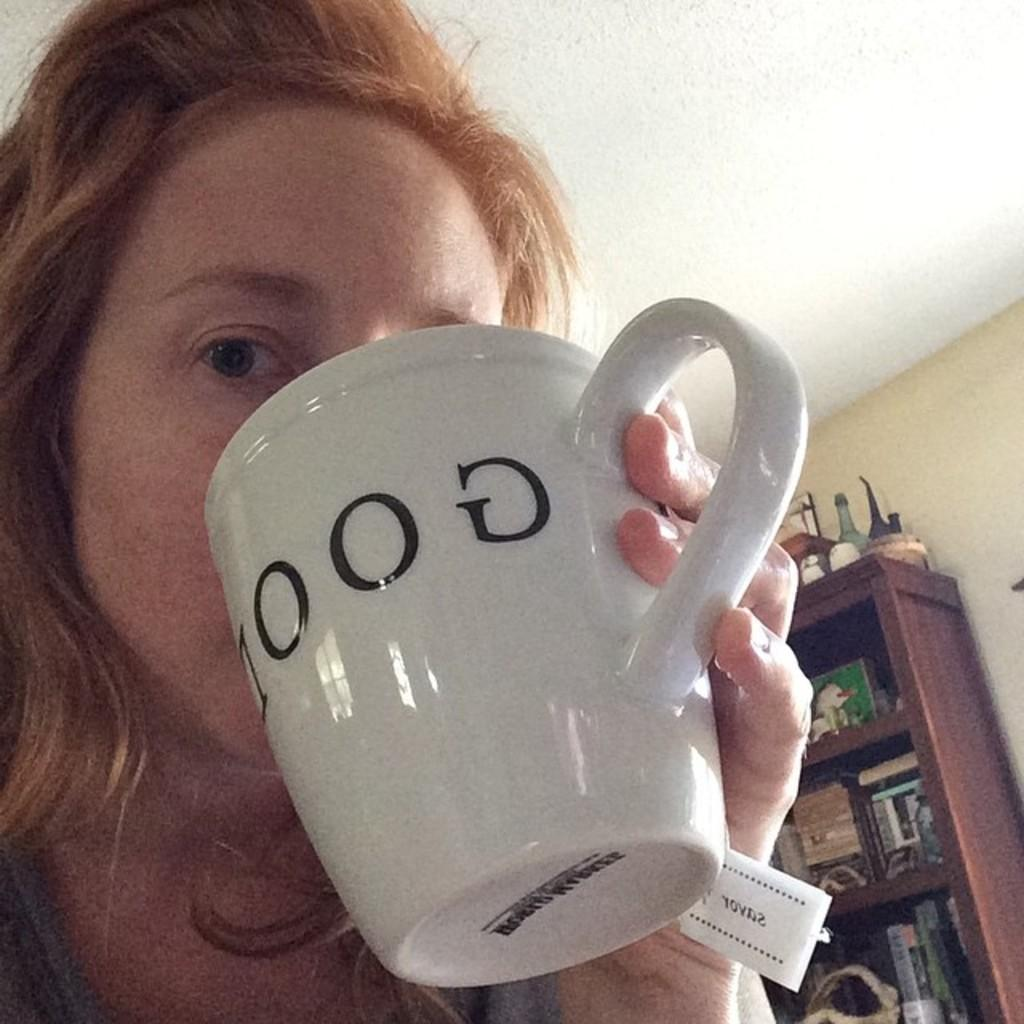Who is present in the image? There is a woman in the image. What is the woman holding in the image? The woman is holding a coffee cup. What can be seen in the background of the image? There is a shelf in the image. What is on the shelf? There are things on the shelf. What type of pain is the woman experiencing in the image? There is no indication in the image that the woman is experiencing any pain. 